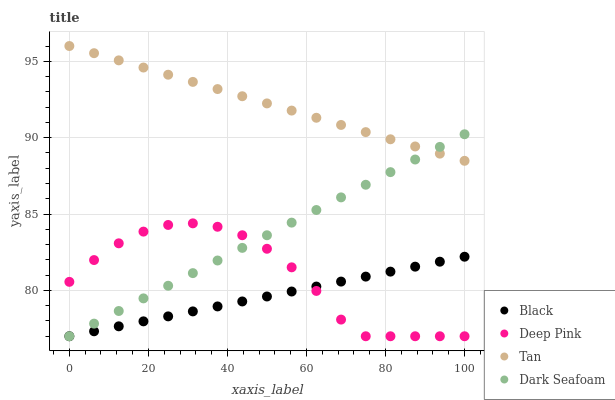Does Black have the minimum area under the curve?
Answer yes or no. Yes. Does Tan have the maximum area under the curve?
Answer yes or no. Yes. Does Deep Pink have the minimum area under the curve?
Answer yes or no. No. Does Deep Pink have the maximum area under the curve?
Answer yes or no. No. Is Tan the smoothest?
Answer yes or no. Yes. Is Deep Pink the roughest?
Answer yes or no. Yes. Is Black the smoothest?
Answer yes or no. No. Is Black the roughest?
Answer yes or no. No. Does Deep Pink have the lowest value?
Answer yes or no. Yes. Does Tan have the highest value?
Answer yes or no. Yes. Does Deep Pink have the highest value?
Answer yes or no. No. Is Deep Pink less than Tan?
Answer yes or no. Yes. Is Tan greater than Deep Pink?
Answer yes or no. Yes. Does Deep Pink intersect Black?
Answer yes or no. Yes. Is Deep Pink less than Black?
Answer yes or no. No. Is Deep Pink greater than Black?
Answer yes or no. No. Does Deep Pink intersect Tan?
Answer yes or no. No. 